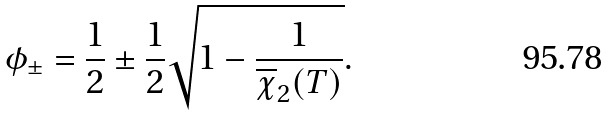<formula> <loc_0><loc_0><loc_500><loc_500>\phi _ { \pm } = \frac { 1 } { 2 } \pm \frac { 1 } { 2 } \sqrt { 1 - \frac { 1 } { \overline { \chi } _ { 2 } ( T ) } } .</formula> 